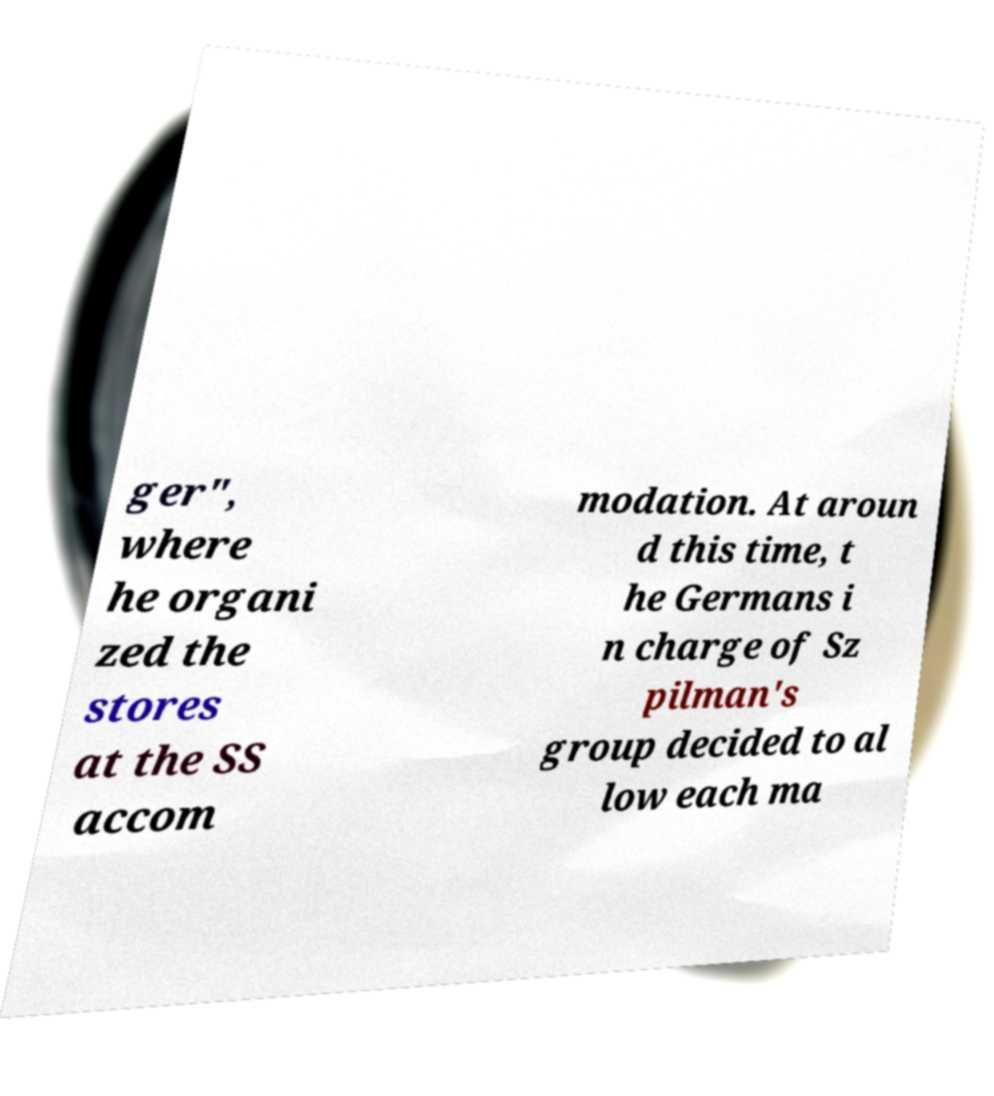Please identify and transcribe the text found in this image. ger", where he organi zed the stores at the SS accom modation. At aroun d this time, t he Germans i n charge of Sz pilman's group decided to al low each ma 